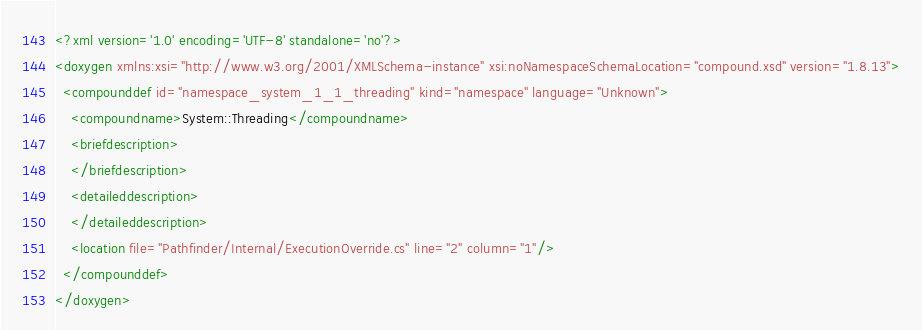<code> <loc_0><loc_0><loc_500><loc_500><_XML_><?xml version='1.0' encoding='UTF-8' standalone='no'?>
<doxygen xmlns:xsi="http://www.w3.org/2001/XMLSchema-instance" xsi:noNamespaceSchemaLocation="compound.xsd" version="1.8.13">
  <compounddef id="namespace_system_1_1_threading" kind="namespace" language="Unknown">
    <compoundname>System::Threading</compoundname>
    <briefdescription>
    </briefdescription>
    <detaileddescription>
    </detaileddescription>
    <location file="Pathfinder/Internal/ExecutionOverride.cs" line="2" column="1"/>
  </compounddef>
</doxygen>
</code> 